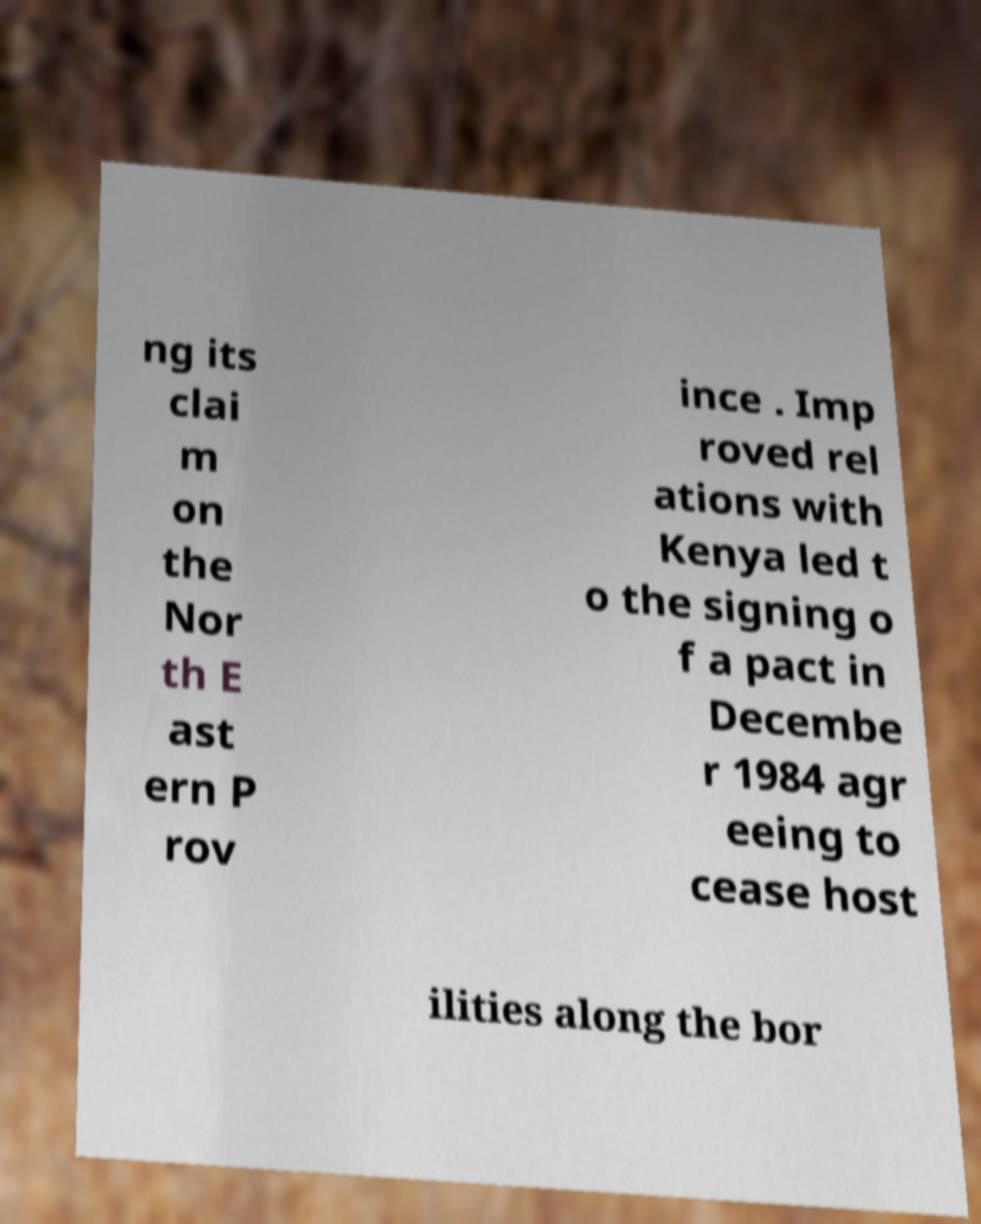Could you extract and type out the text from this image? ng its clai m on the Nor th E ast ern P rov ince . Imp roved rel ations with Kenya led t o the signing o f a pact in Decembe r 1984 agr eeing to cease host ilities along the bor 